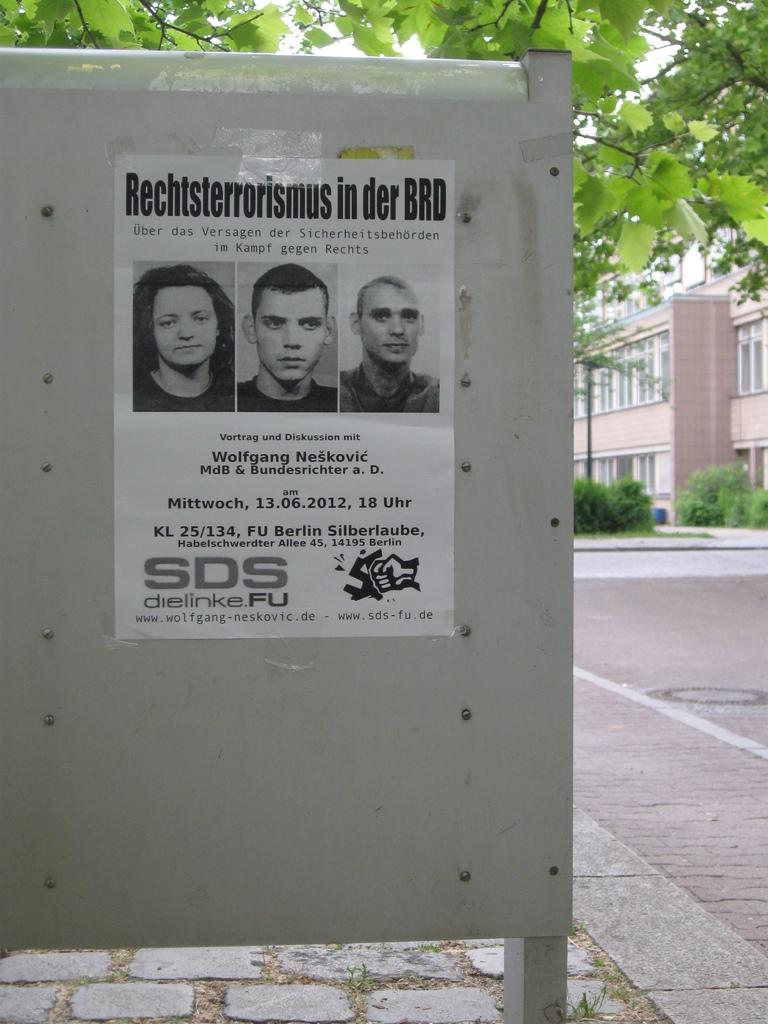What is the main object in the image? There is an iron board in the image. What is attached to the iron board? A poster of three persons is stuck on the iron board. What can be seen in the background of the image? There is a brown color building and a green tree in the background. What type of honey is being collected by the fireman in the image? There is no fireman or honey present in the image; it features an iron board with a poster and a background with a building and a tree. 